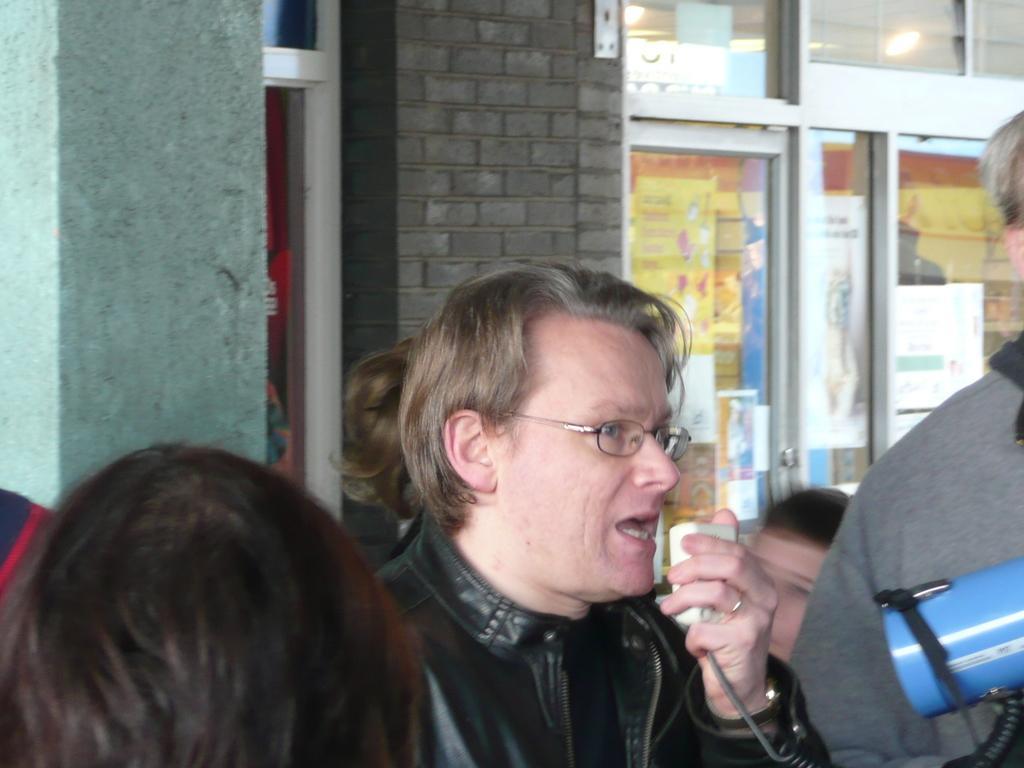In one or two sentences, can you explain what this image depicts? In the picture,there are many people and a person in between them is talking through the Walkman and there is a store behind these people. 